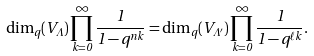Convert formula to latex. <formula><loc_0><loc_0><loc_500><loc_500>\dim _ { q } ( V _ { \Lambda } ) \prod _ { k = 0 } ^ { \infty } \frac { 1 } { 1 - q ^ { n k } } = \dim _ { q } ( V _ { \Lambda ^ { \prime } } ) \prod _ { k = 0 } ^ { \infty } \frac { 1 } { 1 - q ^ { \ell k } } .</formula> 